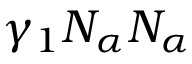Convert formula to latex. <formula><loc_0><loc_0><loc_500><loc_500>\gamma _ { 1 } N _ { \alpha } N _ { \alpha }</formula> 